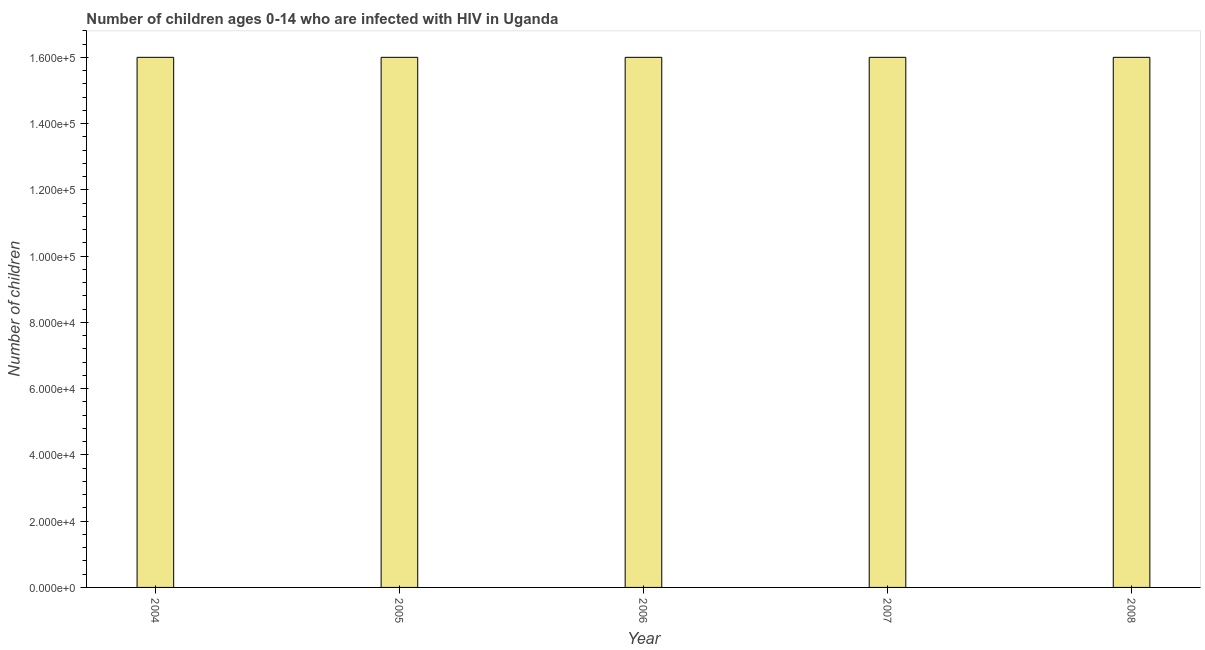What is the title of the graph?
Make the answer very short. Number of children ages 0-14 who are infected with HIV in Uganda. What is the label or title of the X-axis?
Ensure brevity in your answer.  Year. What is the label or title of the Y-axis?
Your answer should be compact. Number of children. In which year was the number of children living with hiv maximum?
Provide a short and direct response. 2004. In which year was the number of children living with hiv minimum?
Give a very brief answer. 2004. What is the difference between the number of children living with hiv in 2004 and 2005?
Your answer should be very brief. 0. What is the median number of children living with hiv?
Your answer should be compact. 1.60e+05. In how many years, is the number of children living with hiv greater than 128000 ?
Keep it short and to the point. 5. Is the difference between the number of children living with hiv in 2006 and 2008 greater than the difference between any two years?
Your answer should be compact. Yes. How many years are there in the graph?
Give a very brief answer. 5. What is the difference between two consecutive major ticks on the Y-axis?
Make the answer very short. 2.00e+04. Are the values on the major ticks of Y-axis written in scientific E-notation?
Offer a terse response. Yes. What is the Number of children in 2005?
Ensure brevity in your answer.  1.60e+05. What is the Number of children in 2007?
Make the answer very short. 1.60e+05. What is the difference between the Number of children in 2004 and 2005?
Give a very brief answer. 0. What is the difference between the Number of children in 2004 and 2007?
Ensure brevity in your answer.  0. What is the difference between the Number of children in 2004 and 2008?
Give a very brief answer. 0. What is the difference between the Number of children in 2005 and 2006?
Give a very brief answer. 0. What is the difference between the Number of children in 2005 and 2007?
Offer a terse response. 0. What is the difference between the Number of children in 2006 and 2007?
Give a very brief answer. 0. What is the ratio of the Number of children in 2004 to that in 2006?
Give a very brief answer. 1. What is the ratio of the Number of children in 2004 to that in 2008?
Offer a terse response. 1. What is the ratio of the Number of children in 2005 to that in 2007?
Provide a short and direct response. 1. What is the ratio of the Number of children in 2005 to that in 2008?
Keep it short and to the point. 1. What is the ratio of the Number of children in 2007 to that in 2008?
Your answer should be very brief. 1. 